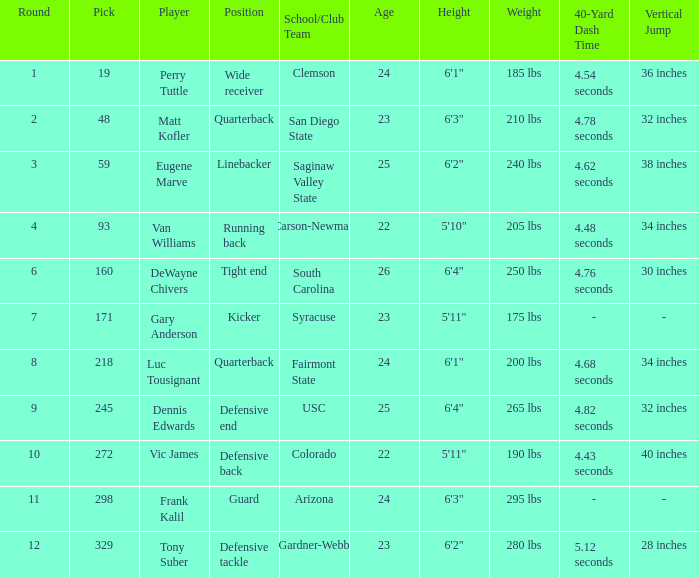Which Round has a School/Club Team of arizona, and a Pick smaller than 298? None. 